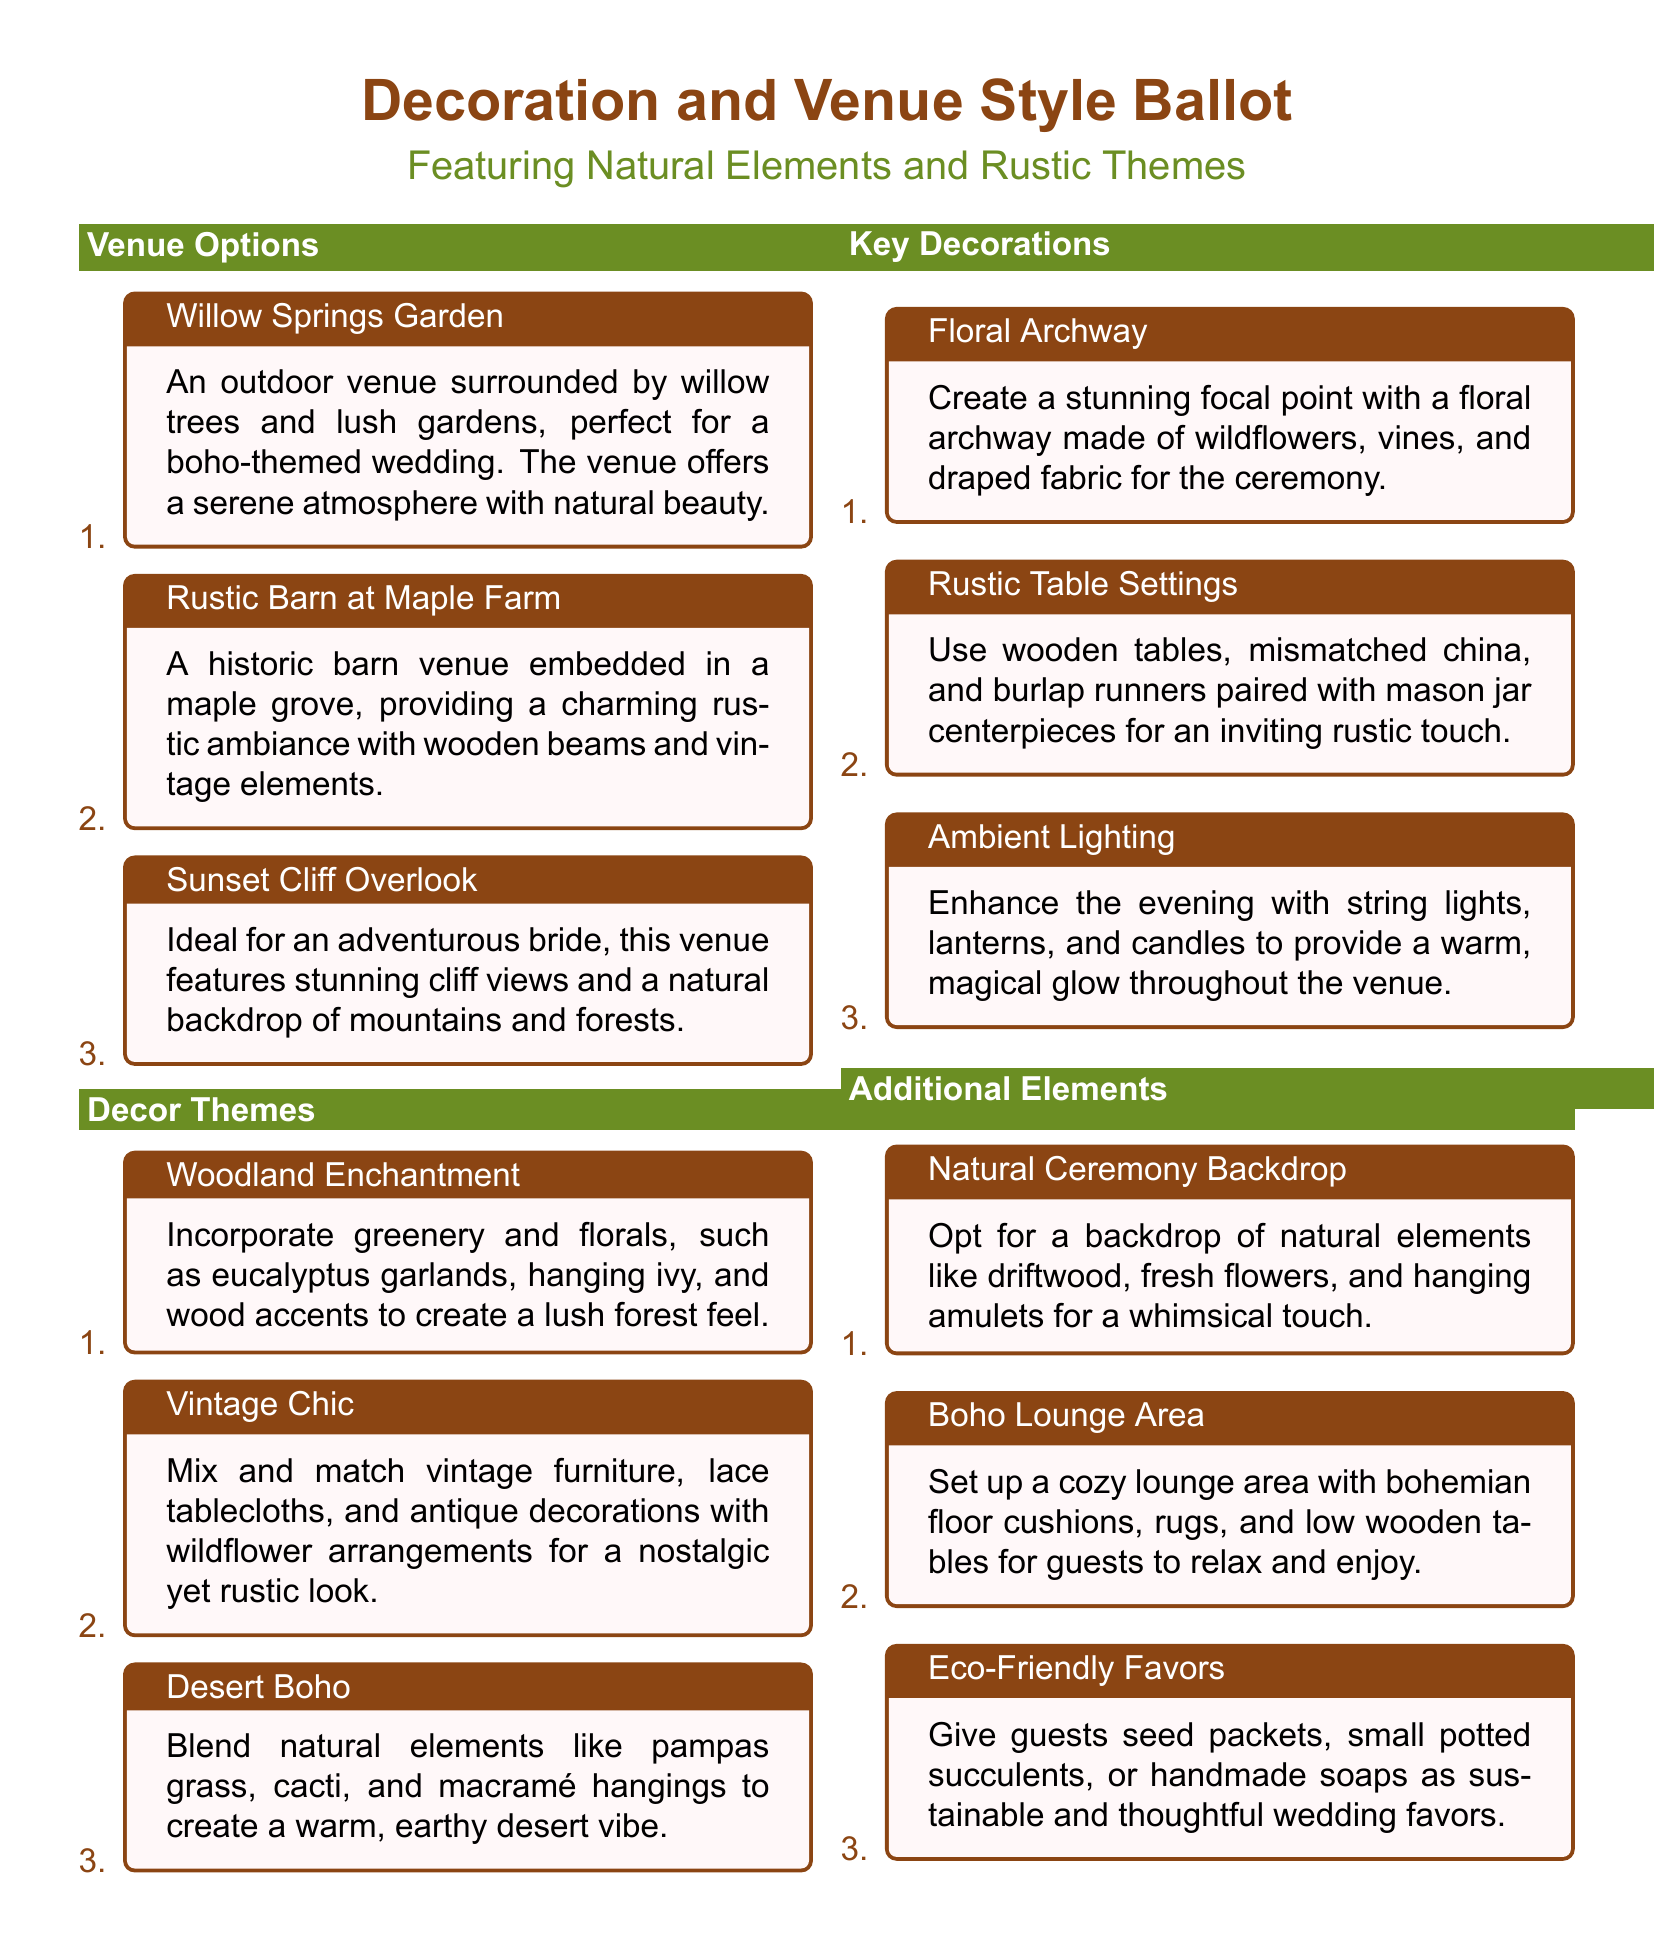What is the first venue option listed? The first venue listed is "Willow Springs Garden," which is described as an outdoor venue surrounded by willow trees and lush gardens.
Answer: Willow Springs Garden What type of decor theme incorporates greenery and florals? The decor theme that incorporates greenery and florals is "Woodland Enchantment."
Answer: Woodland Enchantment What is one of the key decorations mentioned for the ceremony? One of the key decorations mentioned for the ceremony is a "Floral Archway" made of wildflowers, vines, and draped fabric.
Answer: Floral Archway Which venue option is ideal for an adventurous bride? The venue option ideal for an adventurous bride is "Sunset Cliff Overlook," which features stunning cliff views and a natural backdrop.
Answer: Sunset Cliff Overlook How many options are listed under Additional Elements? There are three options listed under Additional Elements, which include a Natural Ceremony Backdrop, Boho Lounge Area, and Eco-Friendly Favors.
Answer: 3 What is the color theme used in the title of the document? The color theme used in the title of the document is a combination of bohogreen and bohobrown.
Answer: Boho green and boho brown What is the purpose of the document? The purpose of the document is to present a ballot for decoration and venue style featuring natural elements and rustic themes for a wedding.
Answer: A ballot for decoration and venue style What type of favors are suggested in the Additional Elements? The type of favors suggested in the Additional Elements are "Eco-Friendly Favors" like seed packets, potted succulents, or handmade soaps.
Answer: Eco-Friendly Favors 